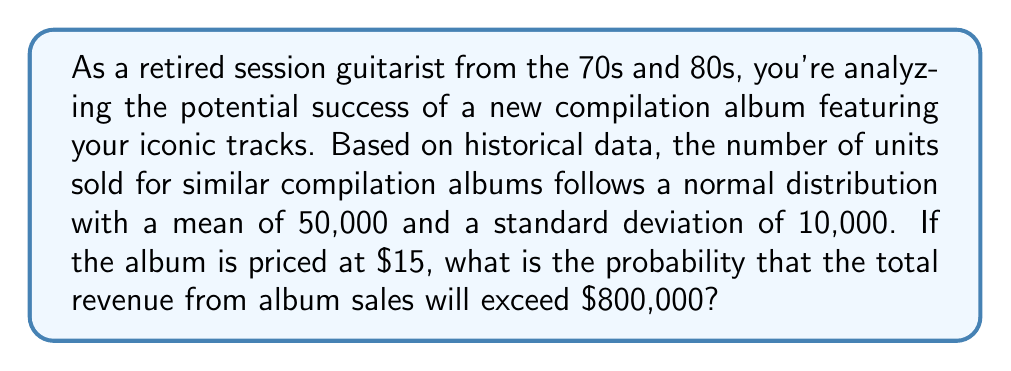Help me with this question. Let's approach this step-by-step:

1) First, we need to determine how many units need to be sold to generate $800,000 in revenue.

   $$\text{Number of units} = \frac{\text{Total revenue}}{\text{Price per unit}} = \frac{\$800,000}{\$15} = 53,333.33$$

   So, we need to sell more than 53,334 units (rounding up) to exceed $800,000 in revenue.

2) We know that the number of units sold follows a normal distribution with:
   
   Mean (μ) = 50,000
   Standard deviation (σ) = 10,000

3) To find the probability of selling more than 53,334 units, we need to calculate the z-score:

   $$z = \frac{x - \mu}{\sigma} = \frac{53,334 - 50,000}{10,000} = 0.3334$$

4) Now, we need to find the probability of Z > 0.3334. We can use the standard normal table or a calculator for this.

5) The area to the right of z = 0.3334 on the standard normal distribution is approximately 0.3694.

Therefore, the probability that the total revenue from album sales will exceed $800,000 is about 0.3694 or 36.94%.
Answer: The probability that the total revenue from album sales will exceed $800,000 is approximately 0.3694 or 36.94%. 